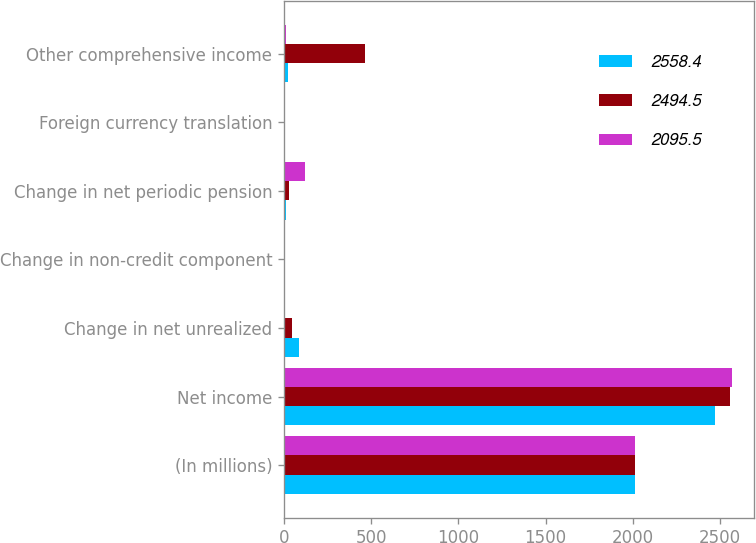<chart> <loc_0><loc_0><loc_500><loc_500><stacked_bar_chart><ecel><fcel>(In millions)<fcel>Net income<fcel>Change in net unrealized<fcel>Change in non-credit component<fcel>Change in net periodic pension<fcel>Foreign currency translation<fcel>Other comprehensive income<nl><fcel>2558.4<fcel>2016<fcel>2469.8<fcel>87.3<fcel>5.4<fcel>13.4<fcel>2.1<fcel>24.7<nl><fcel>2494.5<fcel>2015<fcel>2560<fcel>45.2<fcel>5.6<fcel>26<fcel>3.4<fcel>464.5<nl><fcel>2095.5<fcel>2014<fcel>2569.7<fcel>3.6<fcel>3.9<fcel>118.1<fcel>4.3<fcel>11.3<nl></chart> 